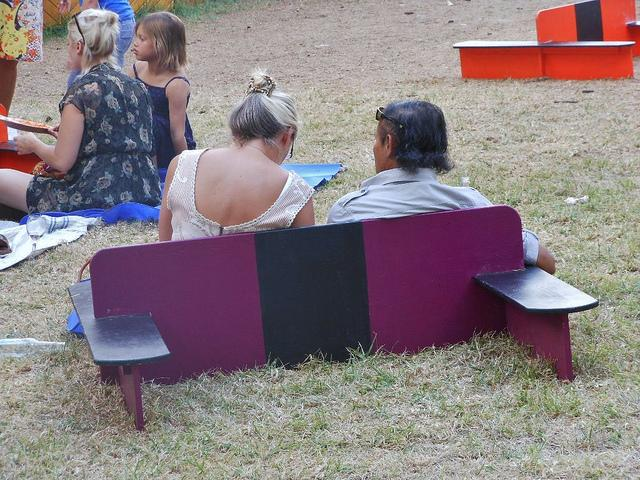Why are they so close together?

Choices:
A) save money
B) little space
C) protection
D) friends friends 